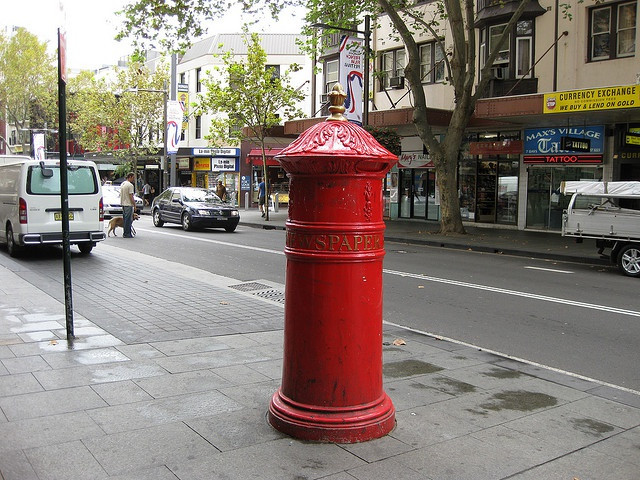Describe the objects in this image and their specific colors. I can see fire hydrant in white, maroon, brown, and black tones, truck in white, lightgray, black, darkgray, and gray tones, truck in white, gray, and black tones, car in white, black, gray, and darkgray tones, and people in white, black, darkgray, and gray tones in this image. 